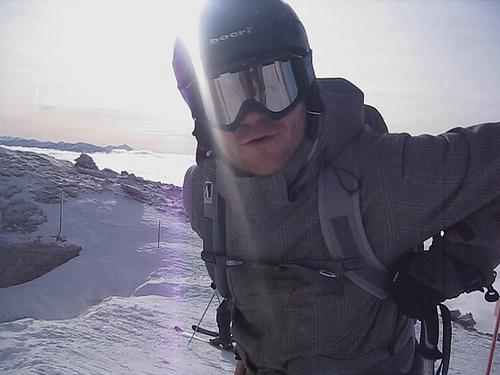What is the significance of the man wearing a helmet and goggles in this image? The man's helmet and goggles indicate that he is engaged in a winter sports activity and that he is taking safety precautions. What is the primary activity captured in the image? A man wearing a helmet and goggles, carrying a backpack and standing in the snow with skiing gear. In the image, mention a particular detail about the person's helmet. The helmet is black and has silver writing on the front. What can one deduce about the person's activity in this image, based on their gear and the surroundings? The person is likely engaged in a winter sports activity, such as skiing or snowboarding, based on their gear and the snowy surroundings. What color are the ski pole and hand gloves in the image? The ski pole is red and the hand gloves are black. Identify a specific aspect of the setting and describe it. There is some light blue sky visible, and mountain peaks can be seen in the distance, indicating a snowy, mountainous landscape. What kind of gear is the person wearing and what might it be used for? The person is wearing a helmet, goggles, gloves, coat, and carrying a backpack, which might be used for skiing or snowboarding. List the key objects in the image and describe their colors and features. Man wearing a black helmet and goggles, carrying a backpack with gray straps, holding a red ski pole, wearing black gloves and a gray coat, standing in the snow with mountains in the background and blue sky visible. Briefly describe the man's facial features and clothing items. The man has scruff on his face, wearing a helmet, goggles, a gray coat, black pants, gloves, and backpack straps across his chest. Can you describe the weather or environment in the image? The environment is snowy and cold with blue sky visible and mountain peaks in the distance. 